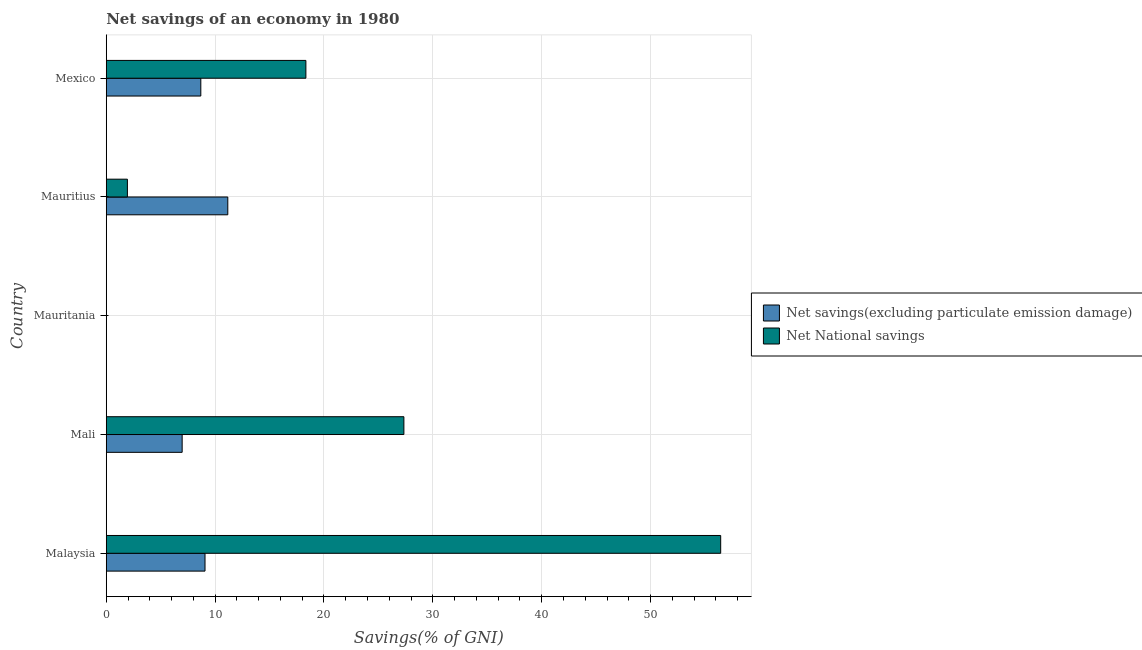Are the number of bars on each tick of the Y-axis equal?
Your answer should be compact. No. How many bars are there on the 4th tick from the top?
Keep it short and to the point. 2. In how many cases, is the number of bars for a given country not equal to the number of legend labels?
Keep it short and to the point. 1. What is the net national savings in Mali?
Your answer should be compact. 27.34. Across all countries, what is the maximum net national savings?
Give a very brief answer. 56.44. In which country was the net national savings maximum?
Ensure brevity in your answer.  Malaysia. What is the total net national savings in the graph?
Offer a terse response. 104.06. What is the difference between the net savings(excluding particulate emission damage) in Malaysia and that in Mexico?
Your response must be concise. 0.39. What is the difference between the net savings(excluding particulate emission damage) in Mexico and the net national savings in Mauritania?
Give a very brief answer. 8.69. What is the average net savings(excluding particulate emission damage) per country?
Ensure brevity in your answer.  7.18. What is the difference between the net national savings and net savings(excluding particulate emission damage) in Mexico?
Offer a terse response. 9.65. What is the ratio of the net national savings in Malaysia to that in Mali?
Your answer should be very brief. 2.06. Is the net national savings in Malaysia less than that in Mali?
Provide a short and direct response. No. What is the difference between the highest and the second highest net national savings?
Your answer should be compact. 29.1. What is the difference between the highest and the lowest net national savings?
Make the answer very short. 56.44. In how many countries, is the net national savings greater than the average net national savings taken over all countries?
Your response must be concise. 2. Is the sum of the net national savings in Malaysia and Mauritius greater than the maximum net savings(excluding particulate emission damage) across all countries?
Give a very brief answer. Yes. How many countries are there in the graph?
Keep it short and to the point. 5. Are the values on the major ticks of X-axis written in scientific E-notation?
Your answer should be compact. No. Does the graph contain any zero values?
Offer a very short reply. Yes. How are the legend labels stacked?
Offer a terse response. Vertical. What is the title of the graph?
Provide a short and direct response. Net savings of an economy in 1980. What is the label or title of the X-axis?
Offer a terse response. Savings(% of GNI). What is the Savings(% of GNI) in Net savings(excluding particulate emission damage) in Malaysia?
Your answer should be very brief. 9.07. What is the Savings(% of GNI) in Net National savings in Malaysia?
Your response must be concise. 56.44. What is the Savings(% of GNI) in Net savings(excluding particulate emission damage) in Mali?
Your answer should be very brief. 6.97. What is the Savings(% of GNI) in Net National savings in Mali?
Give a very brief answer. 27.34. What is the Savings(% of GNI) in Net savings(excluding particulate emission damage) in Mauritius?
Offer a terse response. 11.17. What is the Savings(% of GNI) in Net National savings in Mauritius?
Make the answer very short. 1.94. What is the Savings(% of GNI) in Net savings(excluding particulate emission damage) in Mexico?
Your answer should be compact. 8.69. What is the Savings(% of GNI) of Net National savings in Mexico?
Your answer should be very brief. 18.34. Across all countries, what is the maximum Savings(% of GNI) in Net savings(excluding particulate emission damage)?
Offer a very short reply. 11.17. Across all countries, what is the maximum Savings(% of GNI) of Net National savings?
Your response must be concise. 56.44. Across all countries, what is the minimum Savings(% of GNI) in Net National savings?
Keep it short and to the point. 0. What is the total Savings(% of GNI) in Net savings(excluding particulate emission damage) in the graph?
Your answer should be compact. 35.89. What is the total Savings(% of GNI) of Net National savings in the graph?
Make the answer very short. 104.06. What is the difference between the Savings(% of GNI) of Net savings(excluding particulate emission damage) in Malaysia and that in Mali?
Give a very brief answer. 2.1. What is the difference between the Savings(% of GNI) of Net National savings in Malaysia and that in Mali?
Your answer should be very brief. 29.1. What is the difference between the Savings(% of GNI) of Net savings(excluding particulate emission damage) in Malaysia and that in Mauritius?
Make the answer very short. -2.09. What is the difference between the Savings(% of GNI) in Net National savings in Malaysia and that in Mauritius?
Your response must be concise. 54.49. What is the difference between the Savings(% of GNI) in Net savings(excluding particulate emission damage) in Malaysia and that in Mexico?
Make the answer very short. 0.39. What is the difference between the Savings(% of GNI) of Net National savings in Malaysia and that in Mexico?
Your answer should be very brief. 38.1. What is the difference between the Savings(% of GNI) in Net savings(excluding particulate emission damage) in Mali and that in Mauritius?
Offer a terse response. -4.19. What is the difference between the Savings(% of GNI) in Net National savings in Mali and that in Mauritius?
Ensure brevity in your answer.  25.4. What is the difference between the Savings(% of GNI) of Net savings(excluding particulate emission damage) in Mali and that in Mexico?
Offer a terse response. -1.71. What is the difference between the Savings(% of GNI) of Net National savings in Mali and that in Mexico?
Ensure brevity in your answer.  9. What is the difference between the Savings(% of GNI) of Net savings(excluding particulate emission damage) in Mauritius and that in Mexico?
Ensure brevity in your answer.  2.48. What is the difference between the Savings(% of GNI) of Net National savings in Mauritius and that in Mexico?
Your answer should be very brief. -16.39. What is the difference between the Savings(% of GNI) in Net savings(excluding particulate emission damage) in Malaysia and the Savings(% of GNI) in Net National savings in Mali?
Offer a very short reply. -18.27. What is the difference between the Savings(% of GNI) in Net savings(excluding particulate emission damage) in Malaysia and the Savings(% of GNI) in Net National savings in Mauritius?
Offer a terse response. 7.13. What is the difference between the Savings(% of GNI) in Net savings(excluding particulate emission damage) in Malaysia and the Savings(% of GNI) in Net National savings in Mexico?
Ensure brevity in your answer.  -9.27. What is the difference between the Savings(% of GNI) in Net savings(excluding particulate emission damage) in Mali and the Savings(% of GNI) in Net National savings in Mauritius?
Keep it short and to the point. 5.03. What is the difference between the Savings(% of GNI) of Net savings(excluding particulate emission damage) in Mali and the Savings(% of GNI) of Net National savings in Mexico?
Your answer should be compact. -11.37. What is the difference between the Savings(% of GNI) in Net savings(excluding particulate emission damage) in Mauritius and the Savings(% of GNI) in Net National savings in Mexico?
Offer a terse response. -7.17. What is the average Savings(% of GNI) of Net savings(excluding particulate emission damage) per country?
Provide a succinct answer. 7.18. What is the average Savings(% of GNI) in Net National savings per country?
Your response must be concise. 20.81. What is the difference between the Savings(% of GNI) of Net savings(excluding particulate emission damage) and Savings(% of GNI) of Net National savings in Malaysia?
Your response must be concise. -47.37. What is the difference between the Savings(% of GNI) of Net savings(excluding particulate emission damage) and Savings(% of GNI) of Net National savings in Mali?
Offer a terse response. -20.37. What is the difference between the Savings(% of GNI) of Net savings(excluding particulate emission damage) and Savings(% of GNI) of Net National savings in Mauritius?
Your response must be concise. 9.22. What is the difference between the Savings(% of GNI) in Net savings(excluding particulate emission damage) and Savings(% of GNI) in Net National savings in Mexico?
Your answer should be very brief. -9.65. What is the ratio of the Savings(% of GNI) in Net savings(excluding particulate emission damage) in Malaysia to that in Mali?
Offer a terse response. 1.3. What is the ratio of the Savings(% of GNI) of Net National savings in Malaysia to that in Mali?
Make the answer very short. 2.06. What is the ratio of the Savings(% of GNI) of Net savings(excluding particulate emission damage) in Malaysia to that in Mauritius?
Give a very brief answer. 0.81. What is the ratio of the Savings(% of GNI) of Net National savings in Malaysia to that in Mauritius?
Your response must be concise. 29.04. What is the ratio of the Savings(% of GNI) in Net savings(excluding particulate emission damage) in Malaysia to that in Mexico?
Make the answer very short. 1.04. What is the ratio of the Savings(% of GNI) in Net National savings in Malaysia to that in Mexico?
Your answer should be very brief. 3.08. What is the ratio of the Savings(% of GNI) of Net savings(excluding particulate emission damage) in Mali to that in Mauritius?
Provide a succinct answer. 0.62. What is the ratio of the Savings(% of GNI) of Net National savings in Mali to that in Mauritius?
Give a very brief answer. 14.07. What is the ratio of the Savings(% of GNI) of Net savings(excluding particulate emission damage) in Mali to that in Mexico?
Your answer should be compact. 0.8. What is the ratio of the Savings(% of GNI) in Net National savings in Mali to that in Mexico?
Your response must be concise. 1.49. What is the ratio of the Savings(% of GNI) of Net savings(excluding particulate emission damage) in Mauritius to that in Mexico?
Give a very brief answer. 1.29. What is the ratio of the Savings(% of GNI) of Net National savings in Mauritius to that in Mexico?
Your answer should be compact. 0.11. What is the difference between the highest and the second highest Savings(% of GNI) in Net savings(excluding particulate emission damage)?
Keep it short and to the point. 2.09. What is the difference between the highest and the second highest Savings(% of GNI) of Net National savings?
Provide a short and direct response. 29.1. What is the difference between the highest and the lowest Savings(% of GNI) in Net savings(excluding particulate emission damage)?
Offer a very short reply. 11.17. What is the difference between the highest and the lowest Savings(% of GNI) in Net National savings?
Your answer should be compact. 56.44. 